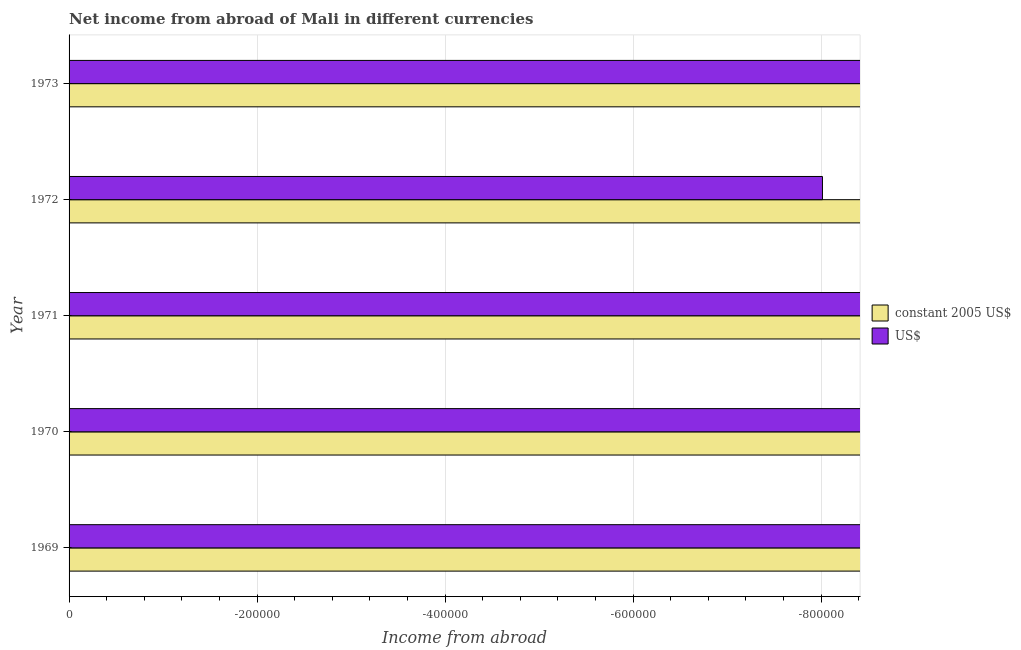How many bars are there on the 2nd tick from the top?
Provide a succinct answer. 0. In how many cases, is the number of bars for a given year not equal to the number of legend labels?
Your answer should be very brief. 5. What is the income from abroad in constant 2005 us$ in 1971?
Your answer should be very brief. 0. What is the total income from abroad in us$ in the graph?
Your response must be concise. 0. In how many years, is the income from abroad in us$ greater than -680000 units?
Your answer should be compact. 0. What is the difference between two consecutive major ticks on the X-axis?
Give a very brief answer. 2.00e+05. Are the values on the major ticks of X-axis written in scientific E-notation?
Ensure brevity in your answer.  No. Does the graph contain any zero values?
Keep it short and to the point. Yes. Where does the legend appear in the graph?
Your response must be concise. Center right. How many legend labels are there?
Your response must be concise. 2. How are the legend labels stacked?
Your answer should be compact. Vertical. What is the title of the graph?
Your answer should be very brief. Net income from abroad of Mali in different currencies. What is the label or title of the X-axis?
Give a very brief answer. Income from abroad. What is the Income from abroad in constant 2005 US$ in 1969?
Give a very brief answer. 0. What is the Income from abroad of US$ in 1969?
Your response must be concise. 0. What is the Income from abroad of US$ in 1971?
Offer a very short reply. 0. 